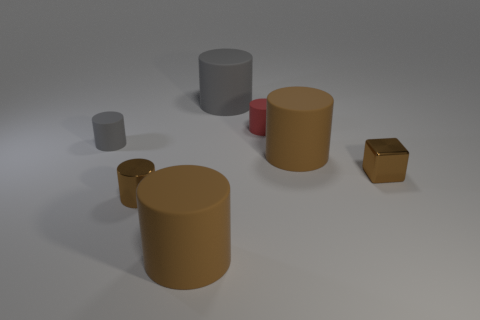What size is the shiny cube that is the same color as the tiny metallic cylinder?
Provide a succinct answer. Small. Does the big brown object that is in front of the tiny brown cylinder have the same shape as the brown shiny thing that is on the left side of the large gray rubber object?
Ensure brevity in your answer.  Yes. How many things are either small rubber cylinders or small brown objects?
Offer a very short reply. 4. There is a big brown thing that is to the left of the large gray object that is behind the red object; what is it made of?
Offer a terse response. Rubber. Are there any other metallic cylinders of the same color as the metallic cylinder?
Provide a succinct answer. No. There is a shiny cylinder that is the same size as the brown metallic block; what is its color?
Provide a short and direct response. Brown. There is a tiny brown thing behind the brown metal cylinder in front of the brown cylinder that is behind the small brown shiny cube; what is it made of?
Offer a terse response. Metal. Do the small metallic cube and the tiny matte object that is to the left of the tiny red thing have the same color?
Your answer should be compact. No. What number of objects are big brown cylinders that are to the left of the small red matte thing or large matte cylinders that are behind the tiny shiny cylinder?
Ensure brevity in your answer.  3. What shape is the metallic object to the left of the large brown matte cylinder in front of the shiny cylinder?
Give a very brief answer. Cylinder. 